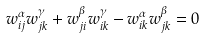Convert formula to latex. <formula><loc_0><loc_0><loc_500><loc_500>w _ { i j } ^ { \alpha } w _ { j k } ^ { \gamma } + w _ { j i } ^ { \beta } w _ { i k } ^ { \gamma } - w _ { i k } ^ { \alpha } w _ { j k } ^ { \beta } = 0</formula> 